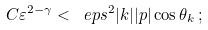<formula> <loc_0><loc_0><loc_500><loc_500>C \varepsilon ^ { 2 - \gamma } < \ e p s ^ { 2 } | k | | p | \cos \theta _ { k } \, ;</formula> 